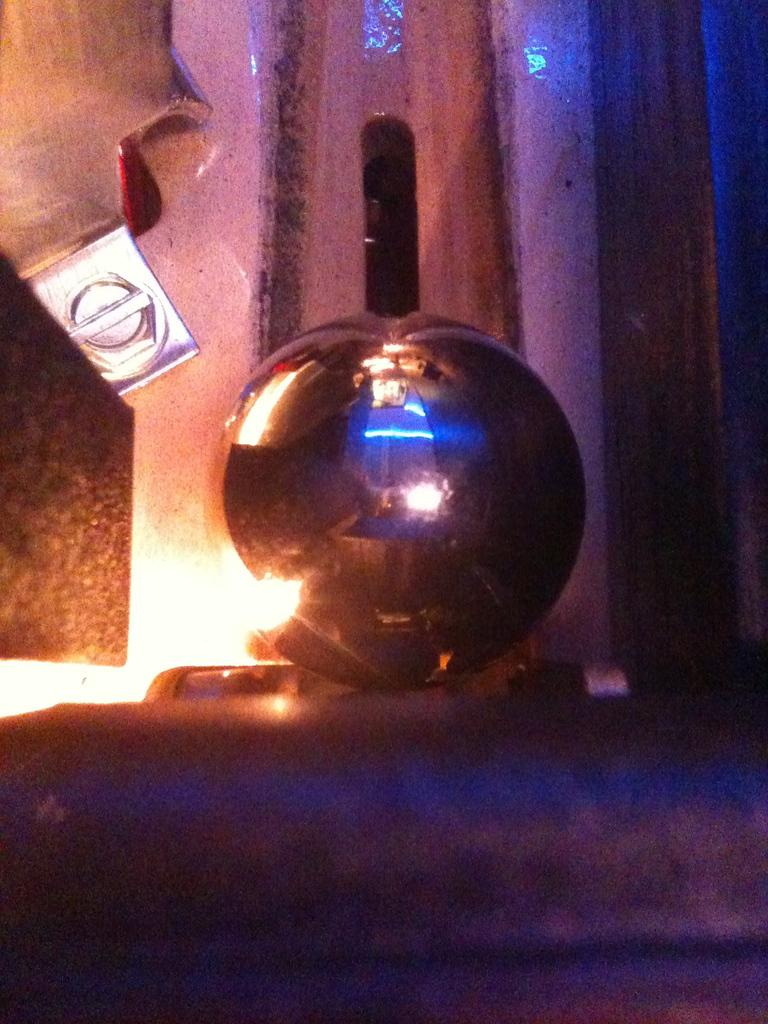What is the main subject or object in the image? There is an undefined object present in the middle of the image. What type of substance is leaking from the undefined object in the image? There is no indication of any substance leaking from the undefined object in the image. 